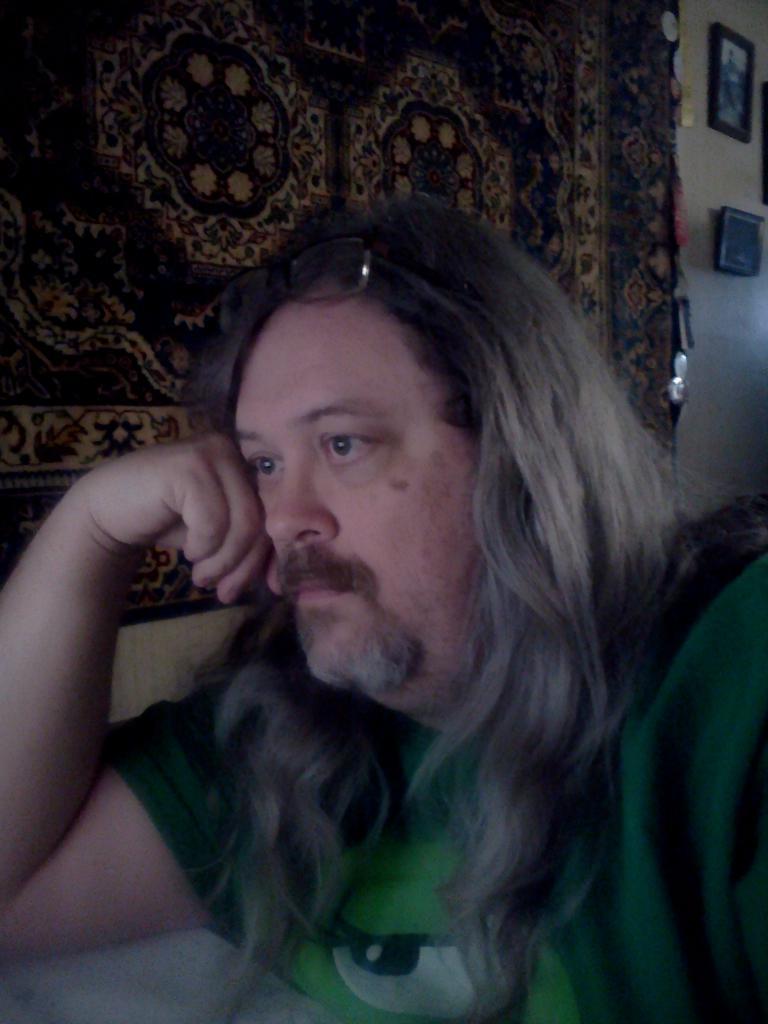In one or two sentences, can you explain what this image depicts? In this picture there is a man who is sitting on the right side of the image, by placing his hand on the table, there are portraits in the top right side of the image. 